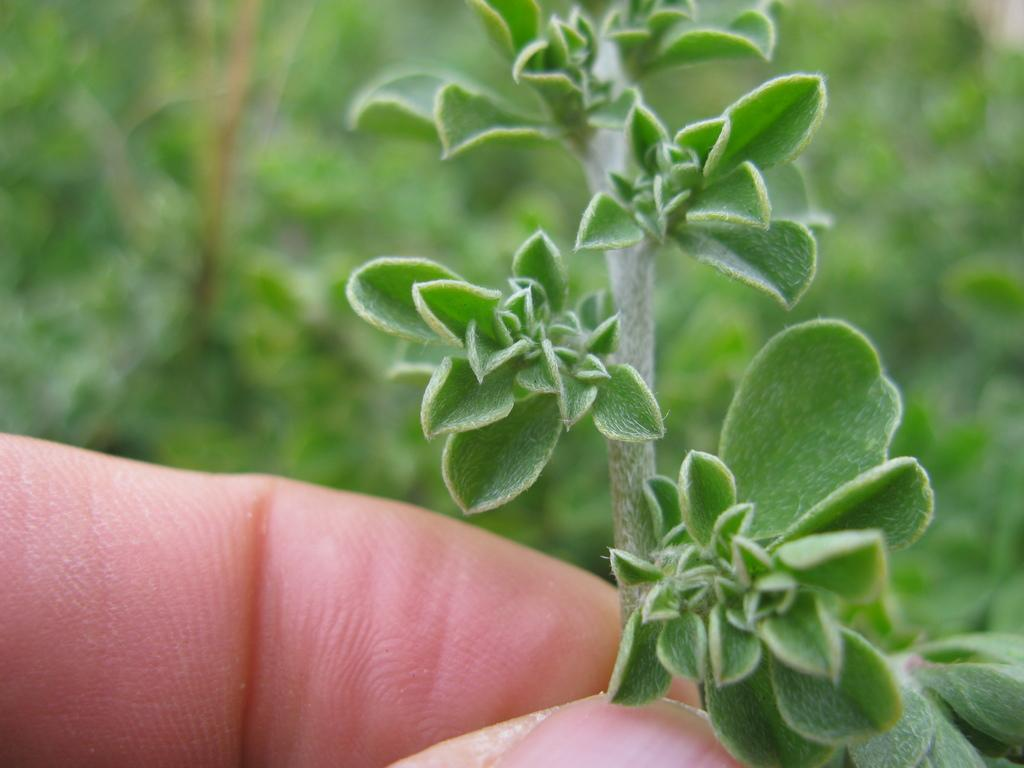What is being held in the human hand in the image? There is a plant in a human hand in the image. What else can be seen in the image besides the plant in the hand? There are plants visible in the background of the image. What type of slope can be seen in the image? There is no slope present in the image; it features a plant in a human hand and plants in the background. 